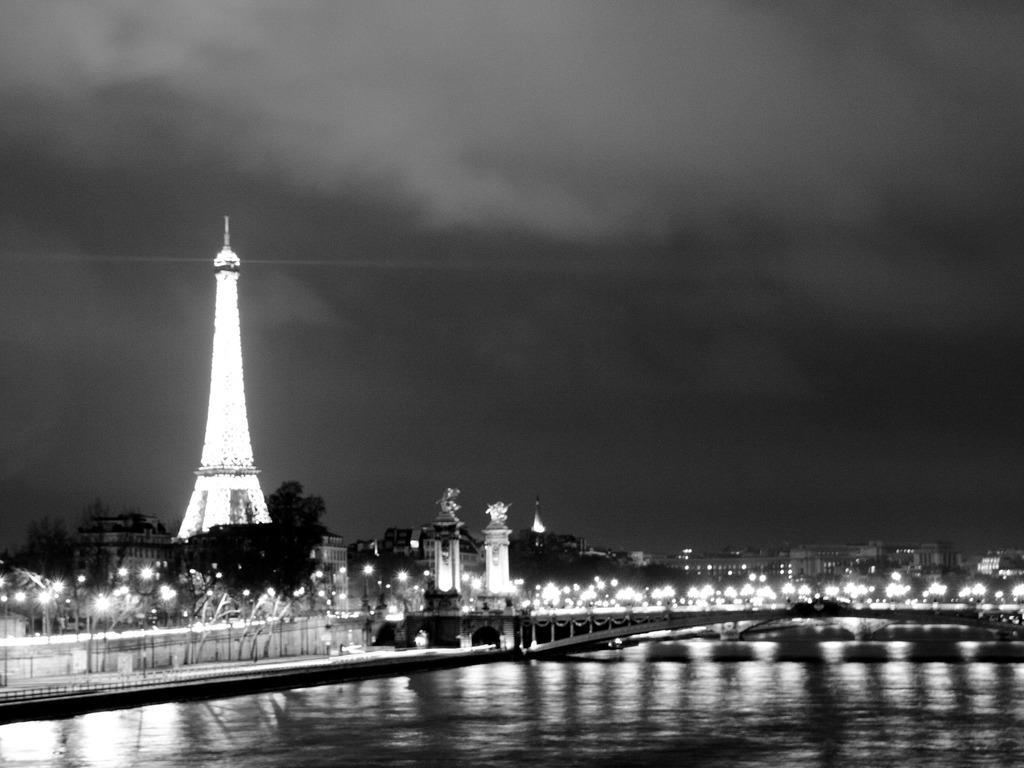Could you give a brief overview of what you see in this image? In the picture we can see a night view of London city with Eiffel tower with full of lights to it and near it, we can see some trees and buildings with lights and we can also see a bridge and under it we can see water. 